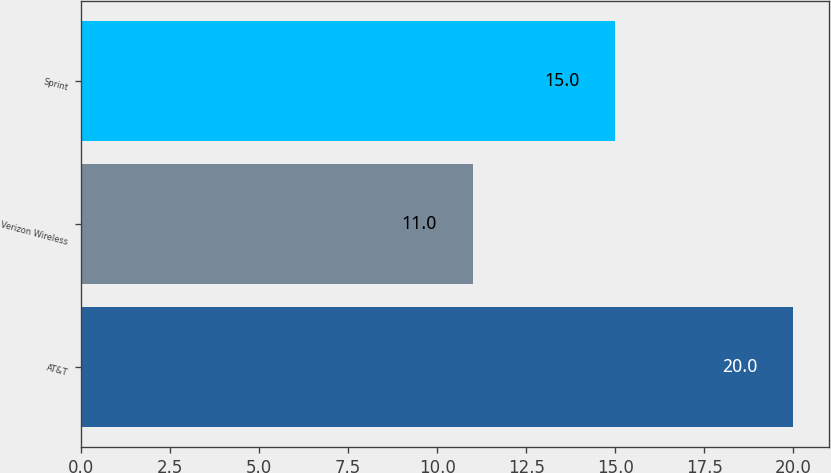Convert chart. <chart><loc_0><loc_0><loc_500><loc_500><bar_chart><fcel>AT&T<fcel>Verizon Wireless<fcel>Sprint<nl><fcel>20<fcel>11<fcel>15<nl></chart> 